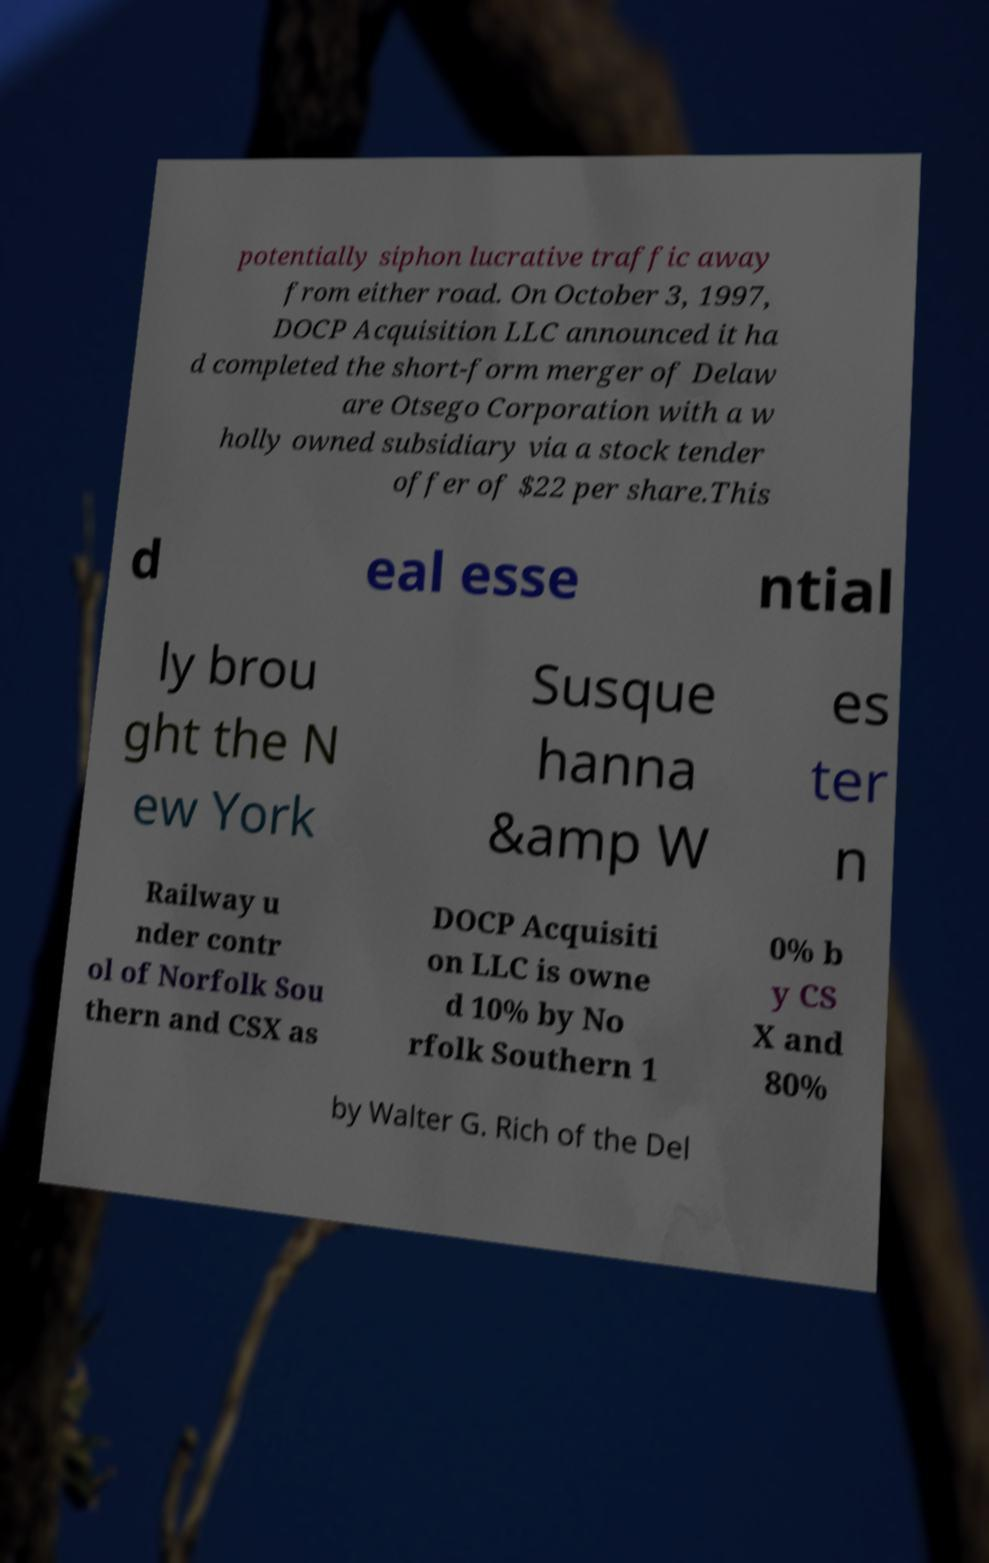There's text embedded in this image that I need extracted. Can you transcribe it verbatim? potentially siphon lucrative traffic away from either road. On October 3, 1997, DOCP Acquisition LLC announced it ha d completed the short-form merger of Delaw are Otsego Corporation with a w holly owned subsidiary via a stock tender offer of $22 per share.This d eal esse ntial ly brou ght the N ew York Susque hanna &amp W es ter n Railway u nder contr ol of Norfolk Sou thern and CSX as DOCP Acquisiti on LLC is owne d 10% by No rfolk Southern 1 0% b y CS X and 80% by Walter G. Rich of the Del 